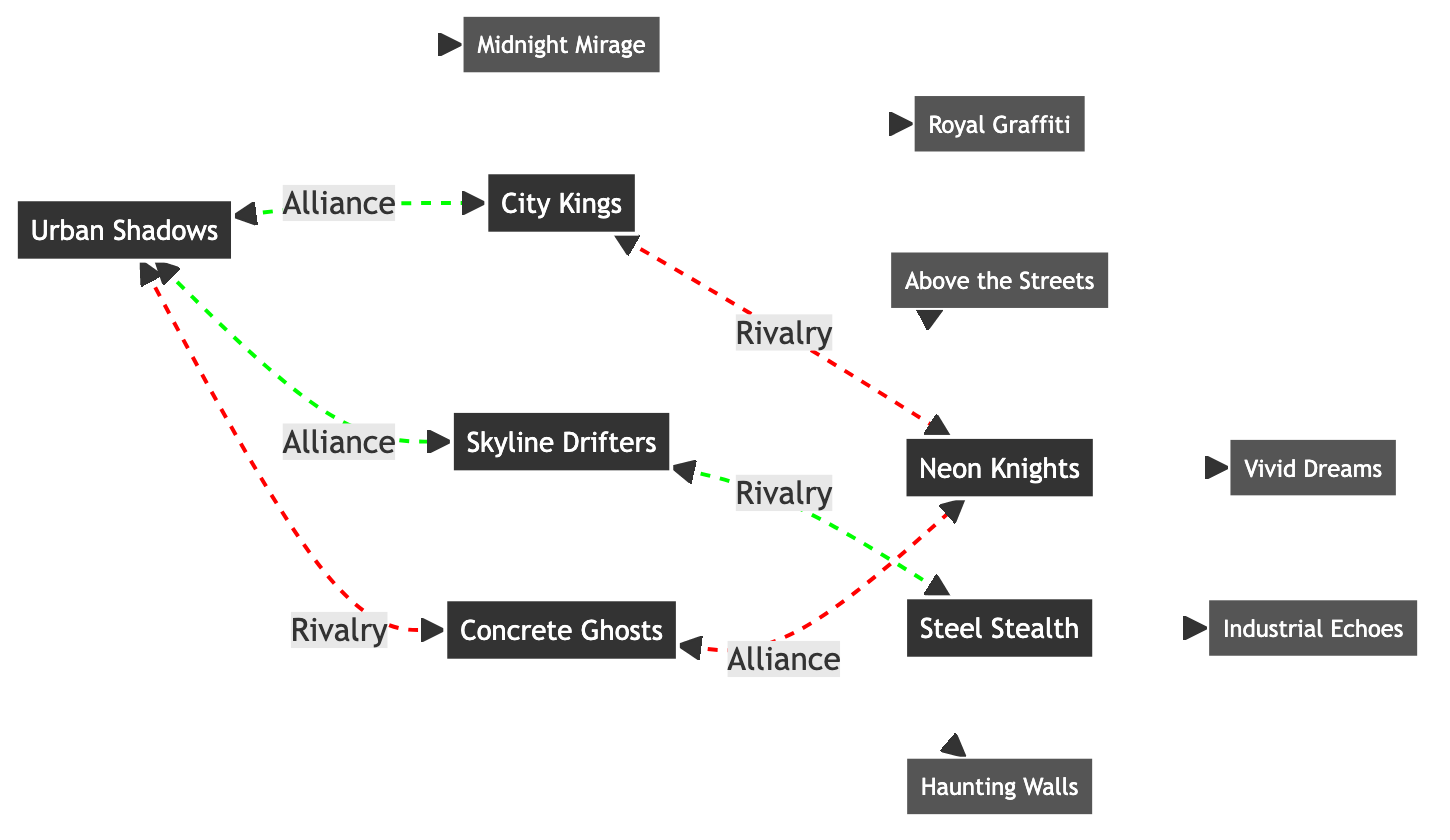What's the best work of Urban Shadows? The best work of Urban Shadows is labeled as "Midnight Mirage" directly connected to the crew in the diagram.
Answer: Midnight Mirage How many rivalries does Skyline Drifters have? The diagram shows that Skyline Drifters has one rivalry, which is with Steel Stealth. This is represented by a single edge from SD to SS marked as a rivalry.
Answer: 1 Which crew has "Vivid Dreams" as their best work? The diagram indicates that "Vivid Dreams" is linked to the crew Neon Knights, as shown by the direct connection between NK and VD.
Answer: Neon Knights What alliances does Urban Shadows have? Urban Shadows is connected to two crews through alliances: City Kings and Skyline Drifters, as denoted by the double-headed arrows between US and CK, and US and SD.
Answer: City Kings, Skyline Drifters What is the rivalry relationship between Concrete Ghosts and Urban Shadows? The diagram shows a rivalry connection between these two crews with a red dashed line from CG to US, indicating a conflicting relationship.
Answer: Rivalry Which crew has the most alliances? By examining the alliances in the diagram, Urban Shadows has the most alliances, tied with two other crews, City Kings, and Skyline Drifters.
Answer: Urban Shadows How many total crews are represented in the diagram? The diagram visually lists six different crews shown with distinct names, each as individual nodes in the graph. Counting these nodes gives a total of six.
Answer: 6 What best work is linked to Concrete Ghosts? The best work associated with Concrete Ghosts is "Haunting Walls," indicated by the direct connection in the graph from CG to HW.
Answer: Haunting Walls Are there any crews without alliances? The diagram shows that Steel Stealth has no alliances, as indicated by the absence of edges connecting SS to other crews in this capacity.
Answer: Yes, Steel Stealth 